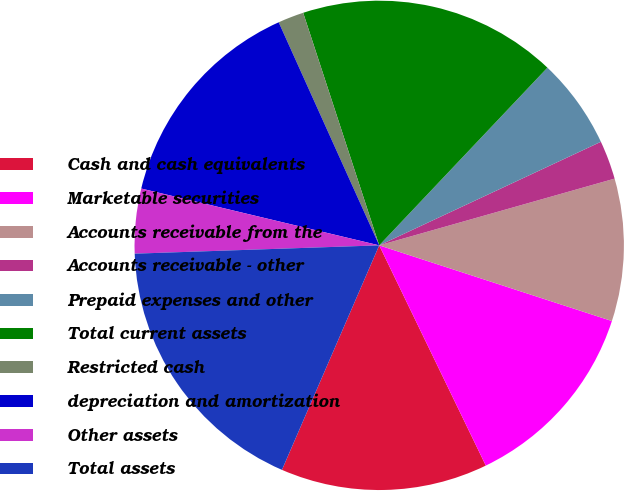<chart> <loc_0><loc_0><loc_500><loc_500><pie_chart><fcel>Cash and cash equivalents<fcel>Marketable securities<fcel>Accounts receivable from the<fcel>Accounts receivable - other<fcel>Prepaid expenses and other<fcel>Total current assets<fcel>Restricted cash<fcel>depreciation and amortization<fcel>Other assets<fcel>Total assets<nl><fcel>13.68%<fcel>12.82%<fcel>9.4%<fcel>2.56%<fcel>5.98%<fcel>17.09%<fcel>1.71%<fcel>14.53%<fcel>4.27%<fcel>17.95%<nl></chart> 